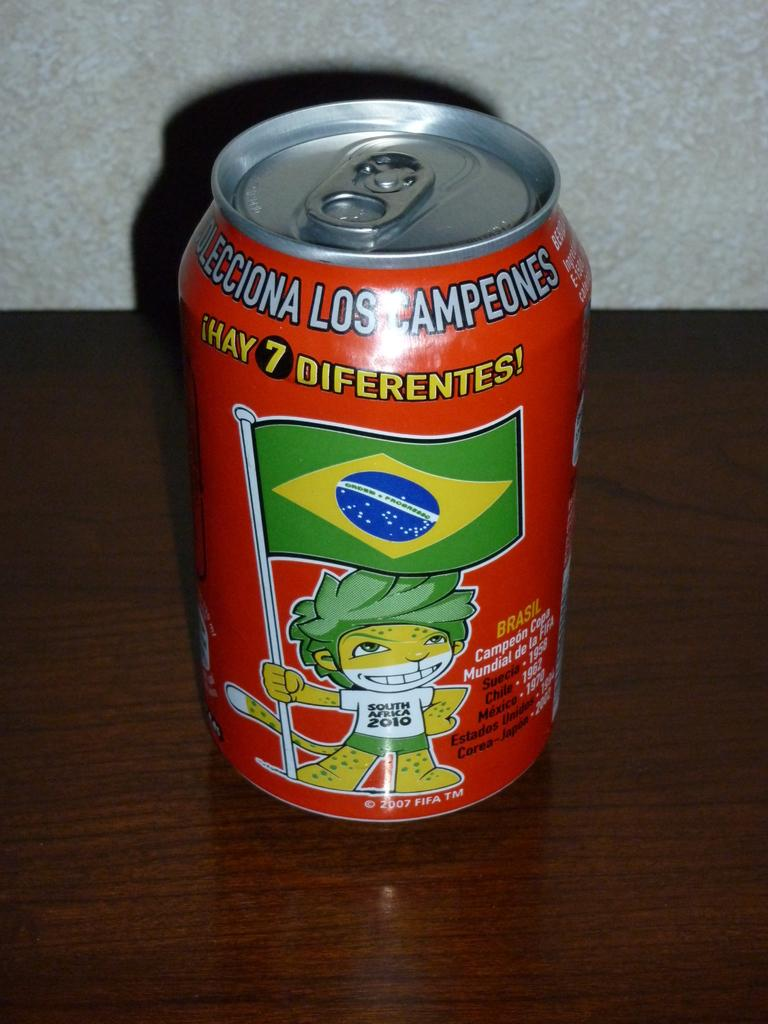<image>
Provide a brief description of the given image. A can from Brazil that is red and says 7 diferntes! 